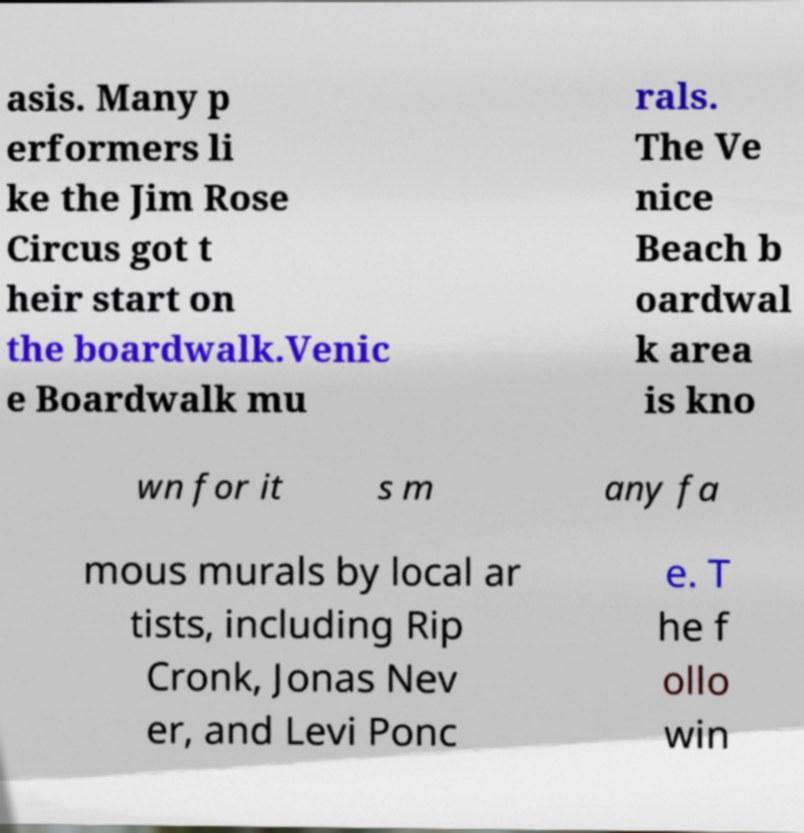Can you accurately transcribe the text from the provided image for me? asis. Many p erformers li ke the Jim Rose Circus got t heir start on the boardwalk.Venic e Boardwalk mu rals. The Ve nice Beach b oardwal k area is kno wn for it s m any fa mous murals by local ar tists, including Rip Cronk, Jonas Nev er, and Levi Ponc e. T he f ollo win 